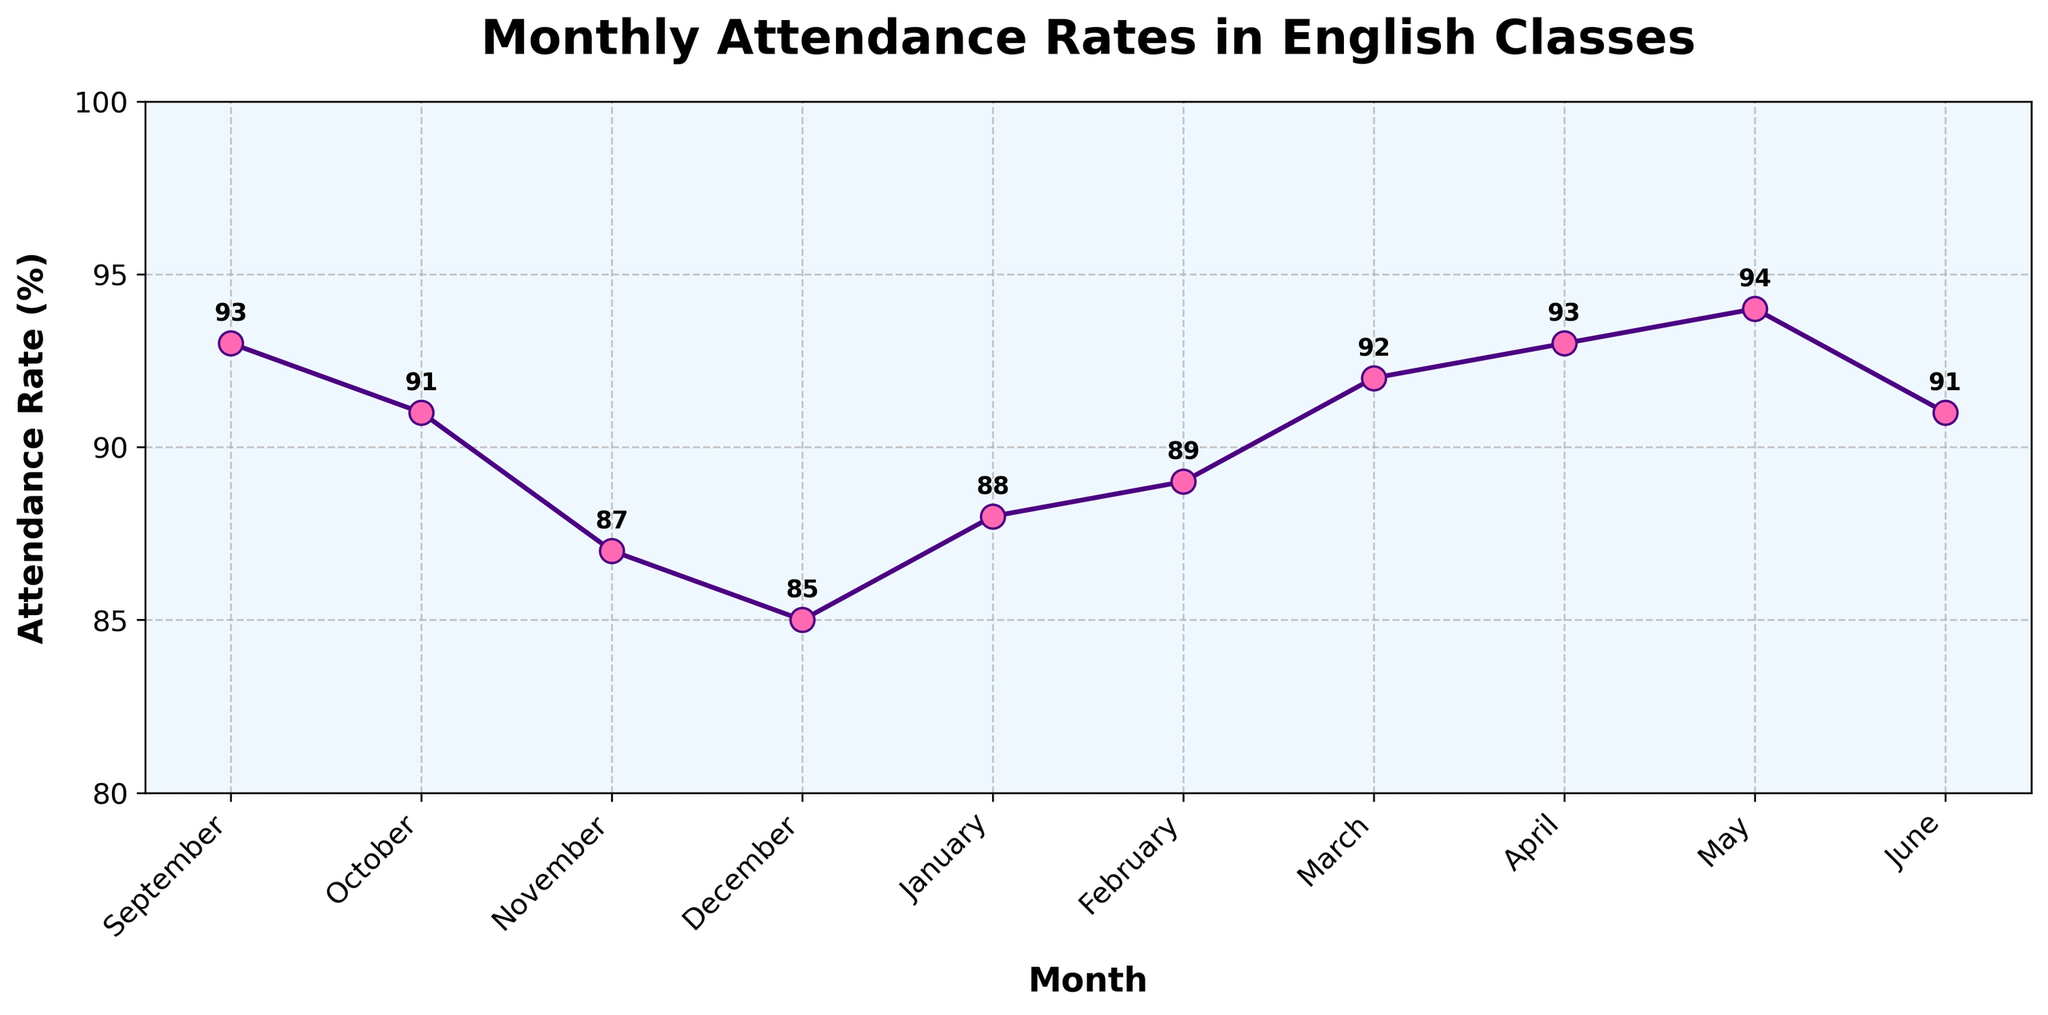What is the title of the plot? The title is usually displayed at the top of the plot and can help in understanding the scope of the data presented. Here, the title is clearly shown as "Monthly Attendance Rates in English Classes."
Answer: Monthly Attendance Rates in English Classes During which month was the attendance rate the highest? To find the month with the highest attendance rate, look for the peak point on the plot. The highest point on the plot is for May, with an attendance rate of 94%.
Answer: May What is the attendance rate for November? Locate November on the x-axis and read the corresponding y-axis value or the label on the plot itself. The attendance rate for November is 87%.
Answer: 87% How does the attendance rate in December compare to the attendance rate in January? Find the attendance rates for both December and January on the plot. December has an attendance rate of 85%, and January has an attendance rate of 88%. January's rate is higher by 3%.
Answer: January is higher by 3% Which month shows a rebound in attendance rate after a drop? To identify a rebound, look for a month where the attendance rate increases after having dropped in the previous month. December to January shows a rebound (from 85% to 88%).
Answer: January Calculate the average attendance rate over the school year. The average can be computed by summing all the attendance rates and then dividing by the number of months. Sum: 93 + 91 + 87 + 85 + 88 + 89 + 92 + 93 + 94 + 91 = 903. Number of months = 10. Average = 903/10.
Answer: 90.3 What trend is observed in the attendance rates from November to January? Examine the plot from November to January. In November, the rate is 87%, it drops to 85% in December, and then rebounds to 88% in January, showing a decline followed by an increase.
Answer: Decline followed by an increase Is there a month where the attendance rate is exactly 90%? Look at the y-axis values and the labels on the plot. No month shows an attendance rate of exactly 90%.
Answer: No How many months have attendance rates above 90%? Count the months for which the y-axis value or label is above 90%. The months are September (93%), March (92%), April (93%), May (94%), and June (91%), totaling 5 months.
Answer: 5 Is the attendance rate more variable in the first half (September to February) or the second half (March to June) of the school year? Calculate the range for both halves. First half range (Sept-Feb): 93% - 85% = 8%. Second half range (Mar-Jun): 94% - 91% = 3%. The first half shows more variability.
Answer: First half 